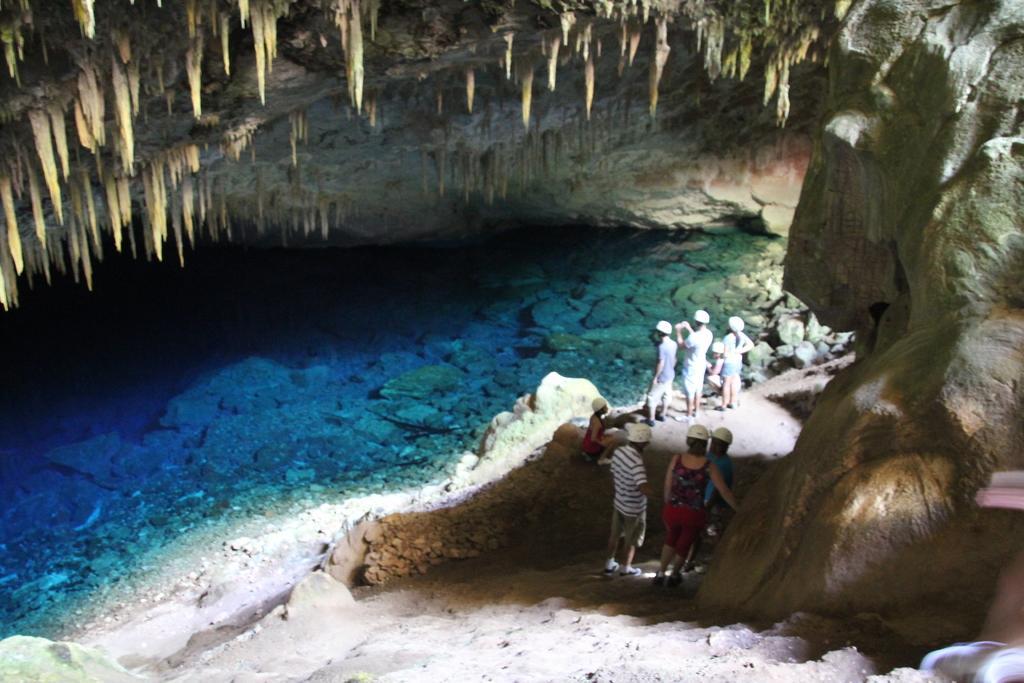Can you describe this image briefly? In this picture we can see a group of people wore helmets and standing on rocks, water. 